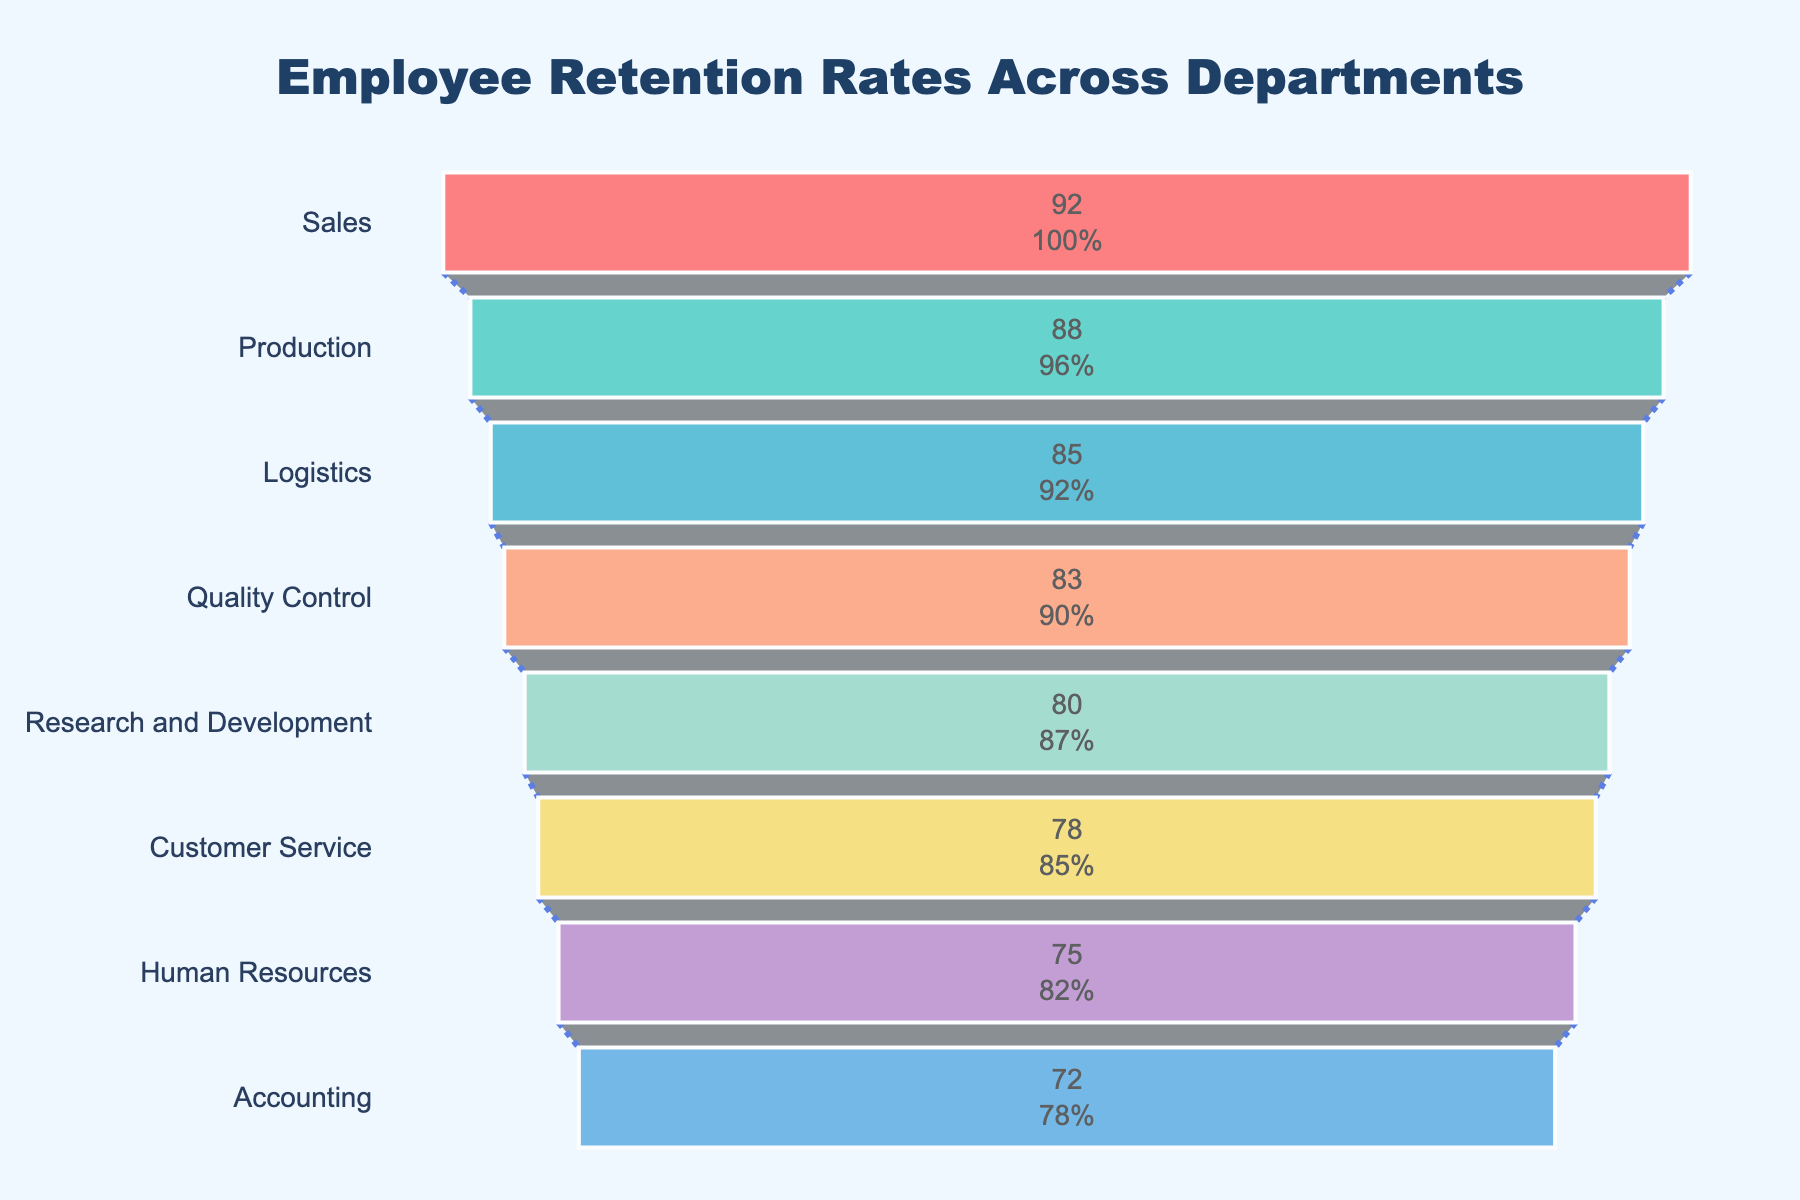Which department has the highest employee retention rate? By observing the top of the funnel chart, the department with the highest retention rate is the one at the widest segment.
Answer: Sales Which department has the lowest employee retention rate? By observing the bottom of the funnel chart, the department with the lowest retention rate is the one at the narrowest segment.
Answer: Accounting How many departments have a retention rate above 80%? By looking at the funnel chart, locate the segments that are above the 80% threshold.
Answer: Five What is the retention rate for the Production department? Identify the segment labeled "Production" in the funnel chart and read the retention rate indicated.
Answer: 88% What is the difference in retention rates between the Sales and Human Resources departments? The retention rate for Sales is 92% and for Human Resources is 75%. Subtract the smaller rate from the larger one (92 - 75).
Answer: 17% If the average retention rate across all departments is required, what would it be? Sum all the retention rates provided (92 + 88 + 85 + 83 + 80 + 78 + 75 + 72) and divide by the number of departments (8). The average retention rate is (653 / 8).
Answer: 81.63% Which department has the closest retention rate to the median retention rate of all departments? To find the median, first sort the retention rates in ascending order: 72, 75, 78, 80, 83, 85, 88, 92. The median is the average of the 4th and 5th values ((80 + 83) / 2 = 81.5). The department closest to this median is “Customer Service” with 78%.
Answer: Customer Service What is the retention rate percentage range from the department with the highest rate to the department with the lowest rate? The highest retention rate is 92% and the lowest is 72%. Calculate the range by subtracting the lowest rate from the highest rate (92 - 72).
Answer: 20% How does the retention rate of Quality Control compare to that of Research and Development? Identify the retention rates for Quality Control (83%) and Research and Development (80%). Compare the two values to determine which is higher.
Answer: Quality Control is 3% higher than Research and Development What percentage of the total initial departments' retention rate is attributed to the Production department alone? First, sum up all the initial retention rates (653). Then, divide the Production department’s rate (88) by the total and multiply by 100 to get the percentage: (88 / 653) * 100.
Answer: 13.48% 